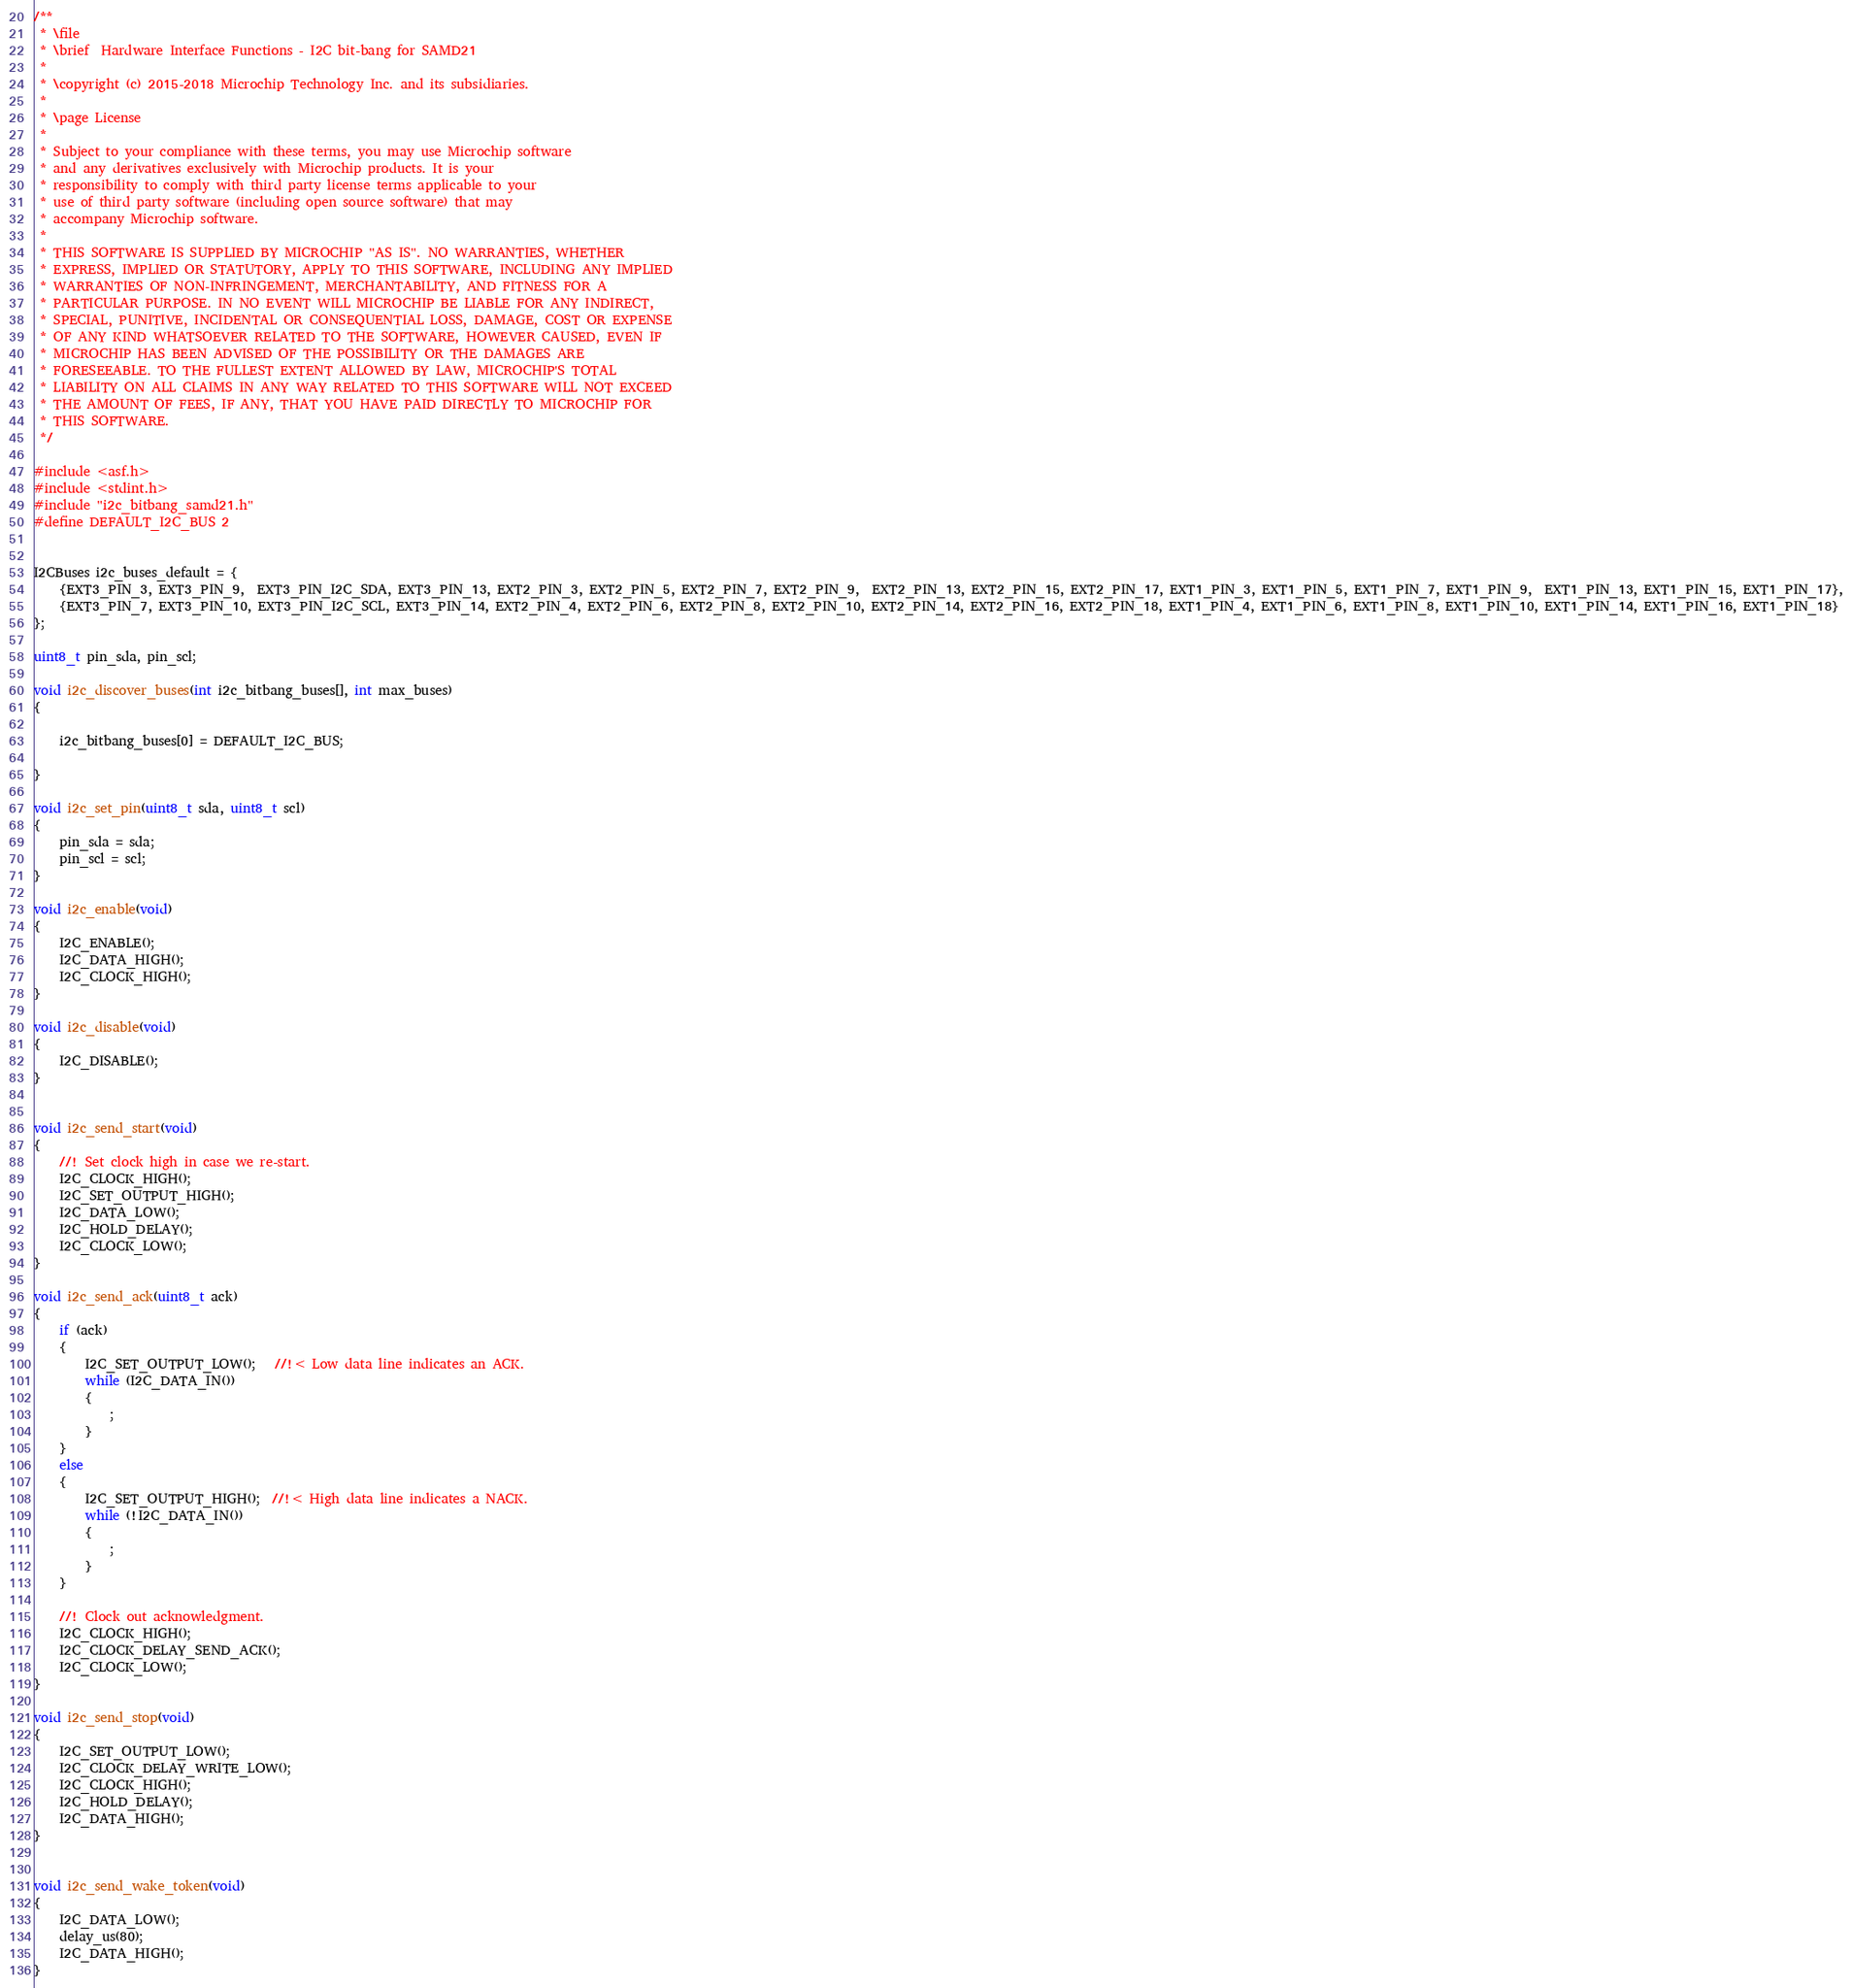Convert code to text. <code><loc_0><loc_0><loc_500><loc_500><_C_>/**
 * \file
 * \brief  Hardware Interface Functions - I2C bit-bang for SAMD21
 *
 * \copyright (c) 2015-2018 Microchip Technology Inc. and its subsidiaries.
 *
 * \page License
 * 
 * Subject to your compliance with these terms, you may use Microchip software
 * and any derivatives exclusively with Microchip products. It is your
 * responsibility to comply with third party license terms applicable to your
 * use of third party software (including open source software) that may
 * accompany Microchip software.
 * 
 * THIS SOFTWARE IS SUPPLIED BY MICROCHIP "AS IS". NO WARRANTIES, WHETHER
 * EXPRESS, IMPLIED OR STATUTORY, APPLY TO THIS SOFTWARE, INCLUDING ANY IMPLIED
 * WARRANTIES OF NON-INFRINGEMENT, MERCHANTABILITY, AND FITNESS FOR A
 * PARTICULAR PURPOSE. IN NO EVENT WILL MICROCHIP BE LIABLE FOR ANY INDIRECT,
 * SPECIAL, PUNITIVE, INCIDENTAL OR CONSEQUENTIAL LOSS, DAMAGE, COST OR EXPENSE
 * OF ANY KIND WHATSOEVER RELATED TO THE SOFTWARE, HOWEVER CAUSED, EVEN IF
 * MICROCHIP HAS BEEN ADVISED OF THE POSSIBILITY OR THE DAMAGES ARE
 * FORESEEABLE. TO THE FULLEST EXTENT ALLOWED BY LAW, MICROCHIP'S TOTAL
 * LIABILITY ON ALL CLAIMS IN ANY WAY RELATED TO THIS SOFTWARE WILL NOT EXCEED
 * THE AMOUNT OF FEES, IF ANY, THAT YOU HAVE PAID DIRECTLY TO MICROCHIP FOR
 * THIS SOFTWARE.
 */

#include <asf.h>
#include <stdint.h>
#include "i2c_bitbang_samd21.h"
#define DEFAULT_I2C_BUS 2


I2CBuses i2c_buses_default = {
    {EXT3_PIN_3, EXT3_PIN_9,  EXT3_PIN_I2C_SDA, EXT3_PIN_13, EXT2_PIN_3, EXT2_PIN_5, EXT2_PIN_7, EXT2_PIN_9,  EXT2_PIN_13, EXT2_PIN_15, EXT2_PIN_17, EXT1_PIN_3, EXT1_PIN_5, EXT1_PIN_7, EXT1_PIN_9,  EXT1_PIN_13, EXT1_PIN_15, EXT1_PIN_17},
    {EXT3_PIN_7, EXT3_PIN_10, EXT3_PIN_I2C_SCL, EXT3_PIN_14, EXT2_PIN_4, EXT2_PIN_6, EXT2_PIN_8, EXT2_PIN_10, EXT2_PIN_14, EXT2_PIN_16, EXT2_PIN_18, EXT1_PIN_4, EXT1_PIN_6, EXT1_PIN_8, EXT1_PIN_10, EXT1_PIN_14, EXT1_PIN_16, EXT1_PIN_18}
};

uint8_t pin_sda, pin_scl;

void i2c_discover_buses(int i2c_bitbang_buses[], int max_buses)
{

    i2c_bitbang_buses[0] = DEFAULT_I2C_BUS;

}

void i2c_set_pin(uint8_t sda, uint8_t scl)
{
    pin_sda = sda;
    pin_scl = scl;
}

void i2c_enable(void)
{
    I2C_ENABLE();
    I2C_DATA_HIGH();
    I2C_CLOCK_HIGH();
}

void i2c_disable(void)
{
    I2C_DISABLE();
}


void i2c_send_start(void)
{
    //! Set clock high in case we re-start.
    I2C_CLOCK_HIGH();
    I2C_SET_OUTPUT_HIGH();
    I2C_DATA_LOW();
    I2C_HOLD_DELAY();
    I2C_CLOCK_LOW();
}

void i2c_send_ack(uint8_t ack)
{
    if (ack)
    {
        I2C_SET_OUTPUT_LOW();   //!< Low data line indicates an ACK.
        while (I2C_DATA_IN())
        {
            ;
        }
    }
    else
    {
        I2C_SET_OUTPUT_HIGH();  //!< High data line indicates a NACK.
        while (!I2C_DATA_IN())
        {
            ;
        }
    }

    //! Clock out acknowledgment.
    I2C_CLOCK_HIGH();
    I2C_CLOCK_DELAY_SEND_ACK();
    I2C_CLOCK_LOW();
}

void i2c_send_stop(void)
{
    I2C_SET_OUTPUT_LOW();
    I2C_CLOCK_DELAY_WRITE_LOW();
    I2C_CLOCK_HIGH();
    I2C_HOLD_DELAY();
    I2C_DATA_HIGH();
}


void i2c_send_wake_token(void)
{
    I2C_DATA_LOW();
    delay_us(80);
    I2C_DATA_HIGH();
}
</code> 